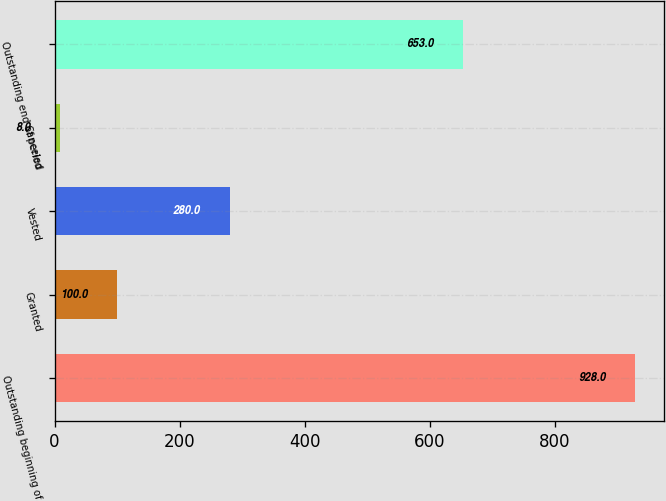<chart> <loc_0><loc_0><loc_500><loc_500><bar_chart><fcel>Outstanding beginning of<fcel>Granted<fcel>Vested<fcel>Canceled<fcel>Outstanding end of period<nl><fcel>928<fcel>100<fcel>280<fcel>8<fcel>653<nl></chart> 